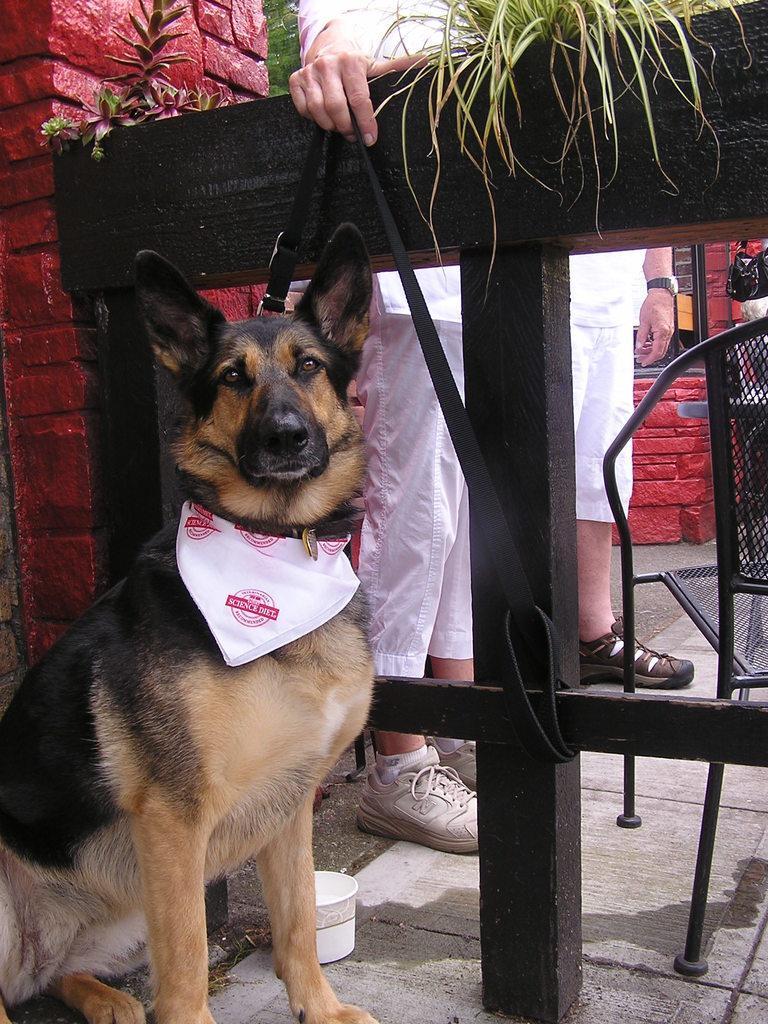In one or two sentences, can you explain what this image depicts? In this image on the left I can see a dog. I can see some people. On the right side, I can see a chair. 